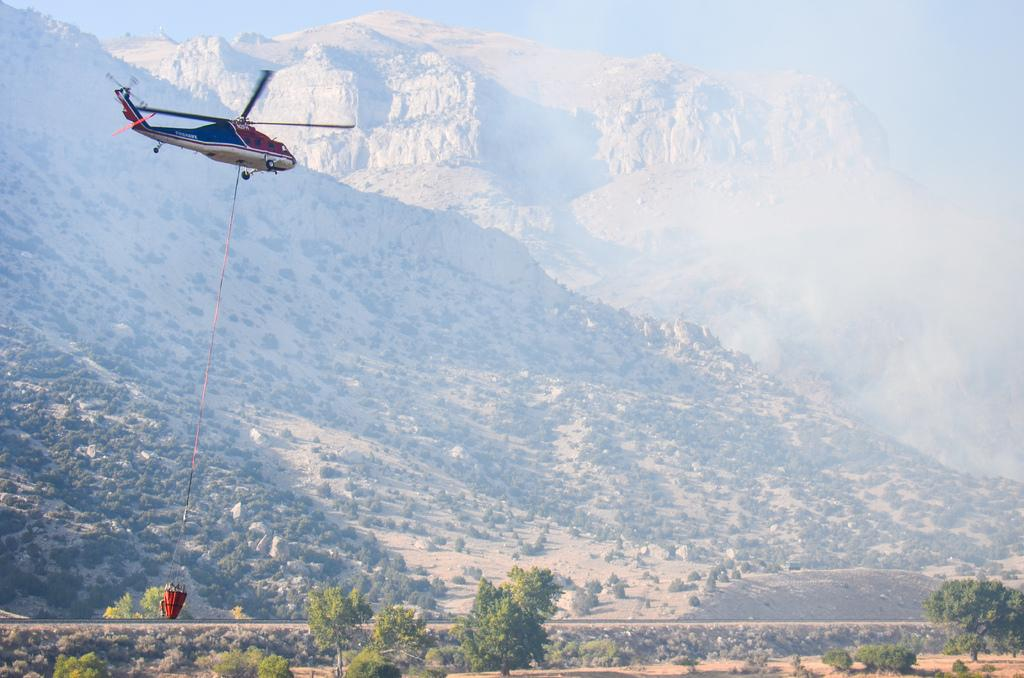What is the main subject of the image? The main subject of the image is an airplane. Is there anything attached to the airplane? Yes, there is a rope attached to the airplane. What is the position of the airplane in the image? The airplane is in the air. What type of natural features can be seen in the image? Trees and hills are visible in the image. What is visible in the background of the image? The sky is visible in the background of the image. What type of wood can be seen in the image? There is no wood present in the image. Is there a letter addressed to someone in the image? There is no letter visible in the image. 